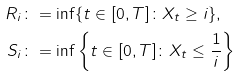Convert formula to latex. <formula><loc_0><loc_0><loc_500><loc_500>R _ { i } & \colon = \inf \{ t \in [ 0 , T ] \colon X _ { t } \geq i \} , \\ S _ { i } & \colon = \inf \left \{ t \in [ 0 , T ] \colon X _ { t } \leq \frac { 1 } { i } \right \}</formula> 